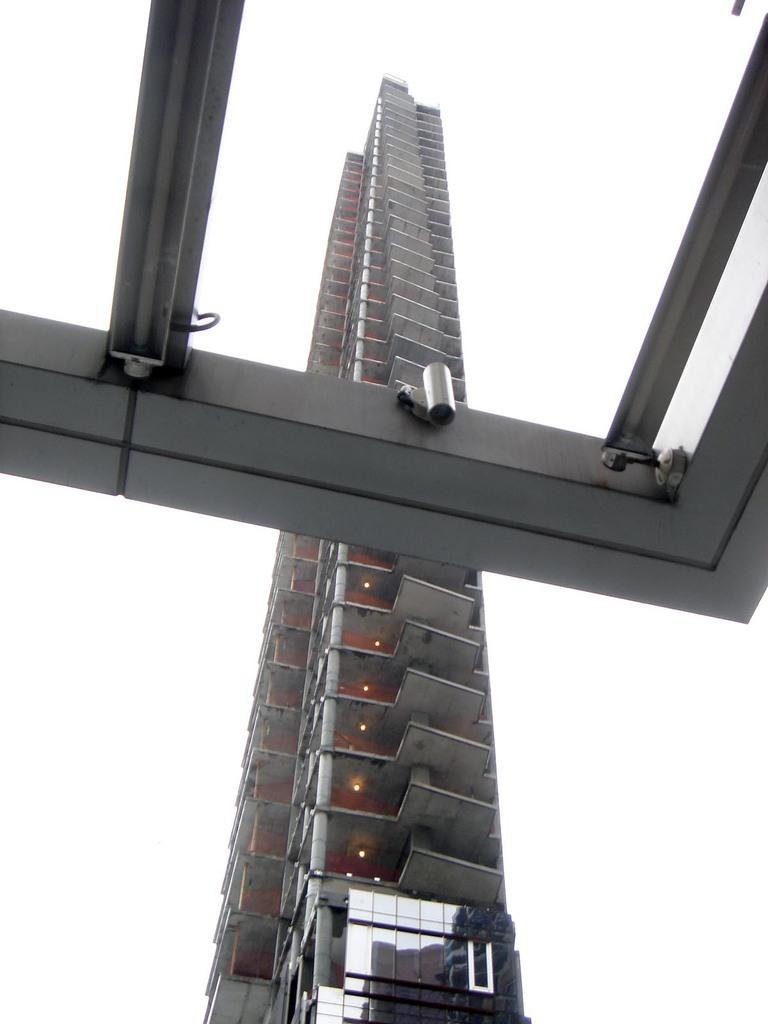What type of structure is the main subject in the image? There is a tall building in the image. Can you describe any specific features of the building? Yes, there is a window at the top of the building in the image. What position does the stranger hold in the building in the image? There is no stranger present in the image, so it is not possible to determine their position in the building. 